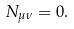Convert formula to latex. <formula><loc_0><loc_0><loc_500><loc_500>N _ { \mu \nu } = 0 .</formula> 